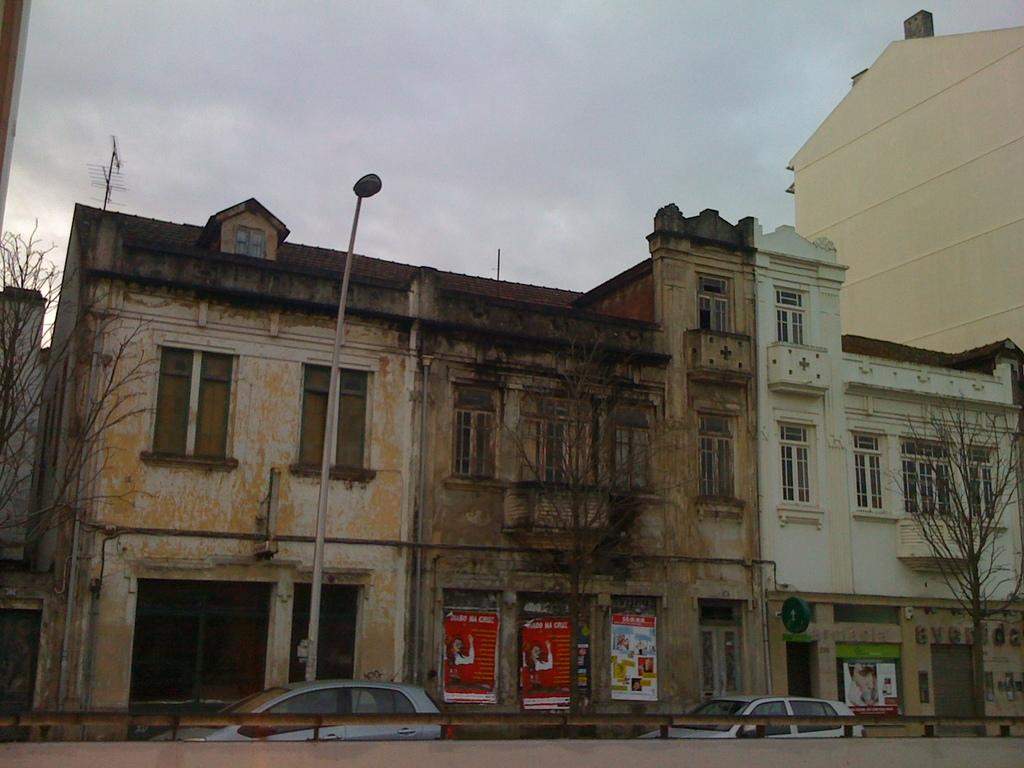What type of structures are visible in the image? There are buildings with walls in the image. What features can be seen on the buildings? The buildings have windows. What other elements can be seen in the image besides buildings? There are trees, a pole with a light, vehicles, posters, and sign boards visible in the image. What is visible in the background of the image? The sky is visible in the background of the image. How many men are standing on the wall in the image? There are no men standing on a wall in the image. 